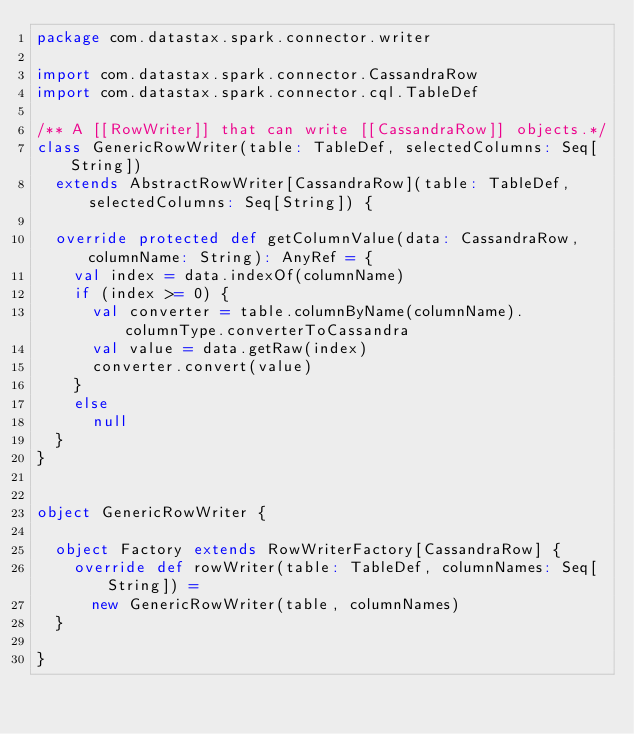Convert code to text. <code><loc_0><loc_0><loc_500><loc_500><_Scala_>package com.datastax.spark.connector.writer

import com.datastax.spark.connector.CassandraRow
import com.datastax.spark.connector.cql.TableDef

/** A [[RowWriter]] that can write [[CassandraRow]] objects.*/
class GenericRowWriter(table: TableDef, selectedColumns: Seq[String])
  extends AbstractRowWriter[CassandraRow](table: TableDef, selectedColumns: Seq[String]) {

  override protected def getColumnValue(data: CassandraRow, columnName: String): AnyRef = {
    val index = data.indexOf(columnName)
    if (index >= 0) {
      val converter = table.columnByName(columnName).columnType.converterToCassandra
      val value = data.getRaw(index)
      converter.convert(value)
    }
    else
      null
  }
}


object GenericRowWriter {

  object Factory extends RowWriterFactory[CassandraRow] {
    override def rowWriter(table: TableDef, columnNames: Seq[String]) =
      new GenericRowWriter(table, columnNames)
  }

}
</code> 